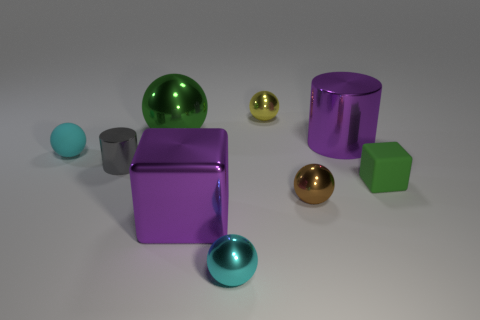Is the big shiny sphere the same color as the small matte cube?
Ensure brevity in your answer.  Yes. What color is the other cylinder that is made of the same material as the gray cylinder?
Keep it short and to the point. Purple. What is the green sphere that is behind the rubber thing that is left of the large object in front of the green cube made of?
Keep it short and to the point. Metal. Do the cyan sphere that is in front of the green rubber cube and the gray shiny cylinder have the same size?
Offer a terse response. Yes. How many big things are either cylinders or cubes?
Give a very brief answer. 2. Is there a metal object of the same color as the large block?
Provide a short and direct response. Yes. There is a purple object that is the same size as the metallic block; what shape is it?
Make the answer very short. Cylinder. There is a ball that is right of the small yellow metal object; is it the same color as the large metallic cylinder?
Keep it short and to the point. No. How many things are either cyan balls that are behind the tiny rubber block or small cyan objects?
Provide a short and direct response. 2. Is the number of small objects right of the tiny gray cylinder greater than the number of green blocks to the left of the big green object?
Ensure brevity in your answer.  Yes. 